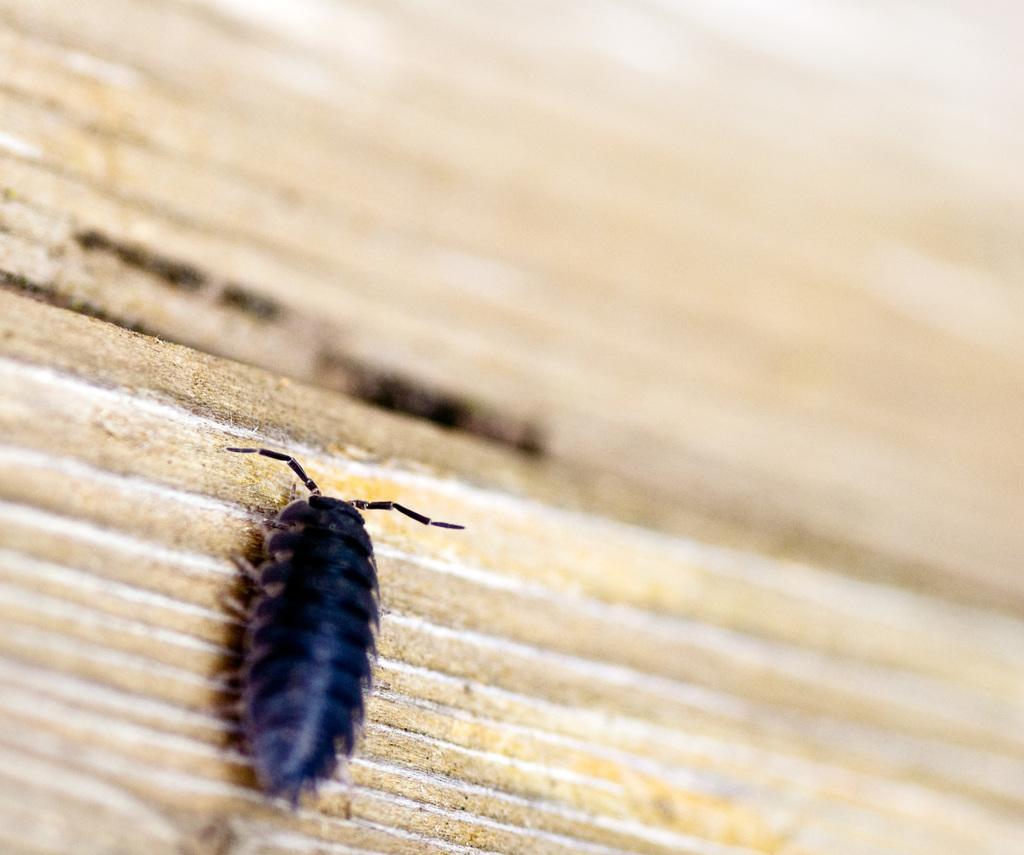How would you summarize this image in a sentence or two? In this image there is an insect on the path, and there is blur background. 